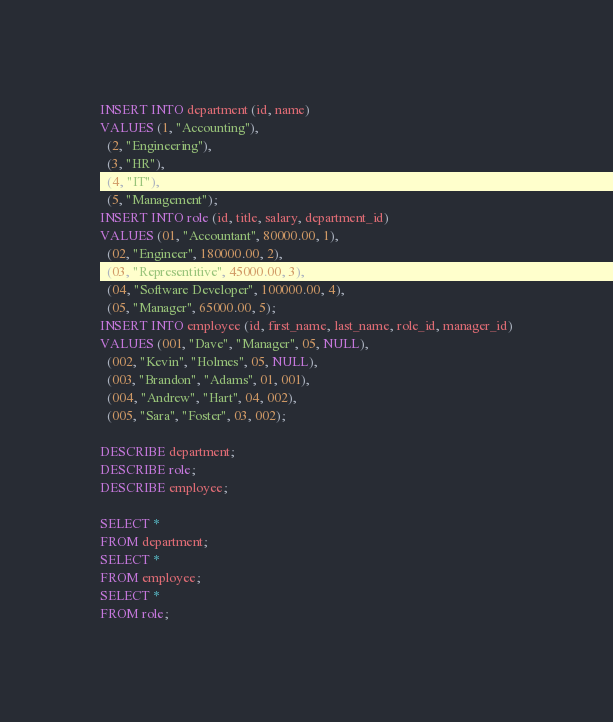<code> <loc_0><loc_0><loc_500><loc_500><_SQL_>INSERT INTO department (id, name)
VALUES (1, "Accounting"),
  (2, "Engineering"),
  (3, "HR"),
  (4, "IT"),
  (5, "Management");
INSERT INTO role (id, title, salary, department_id)
VALUES (01, "Accountant", 80000.00, 1),
  (02, "Engineer", 180000.00, 2),
  (03, "Representitive", 45000.00, 3),
  (04, "Software Developer", 100000.00, 4),
  (05, "Manager", 65000.00, 5);
INSERT INTO employee (id, first_name, last_name, role_id, manager_id)
VALUES (001, "Dave", "Manager", 05, NULL),
  (002, "Kevin", "Holmes", 05, NULL),
  (003, "Brandon", "Adams", 01, 001),
  (004, "Andrew", "Hart", 04, 002),
  (005, "Sara", "Foster", 03, 002);

DESCRIBE department;
DESCRIBE role;
DESCRIBE employee;

SELECT *
FROM department;
SELECT *
FROM employee;
SELECT *
FROM role;</code> 